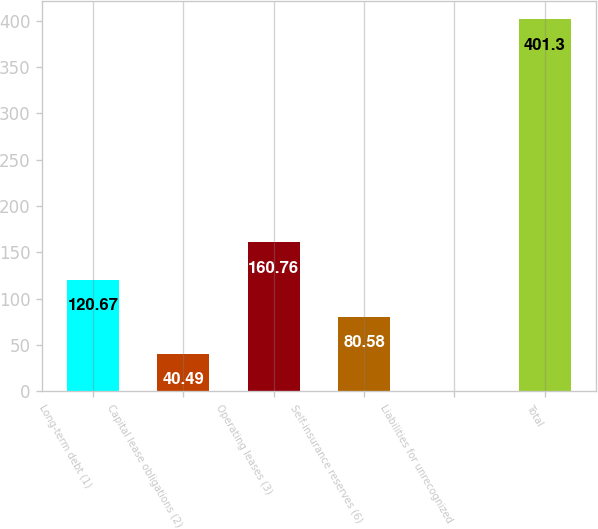Convert chart. <chart><loc_0><loc_0><loc_500><loc_500><bar_chart><fcel>Long-term debt (1)<fcel>Capital lease obligations (2)<fcel>Operating leases (3)<fcel>Self-insurance reserves (6)<fcel>Liabilities for unrecognized<fcel>Total<nl><fcel>120.67<fcel>40.49<fcel>160.76<fcel>80.58<fcel>0.4<fcel>401.3<nl></chart> 